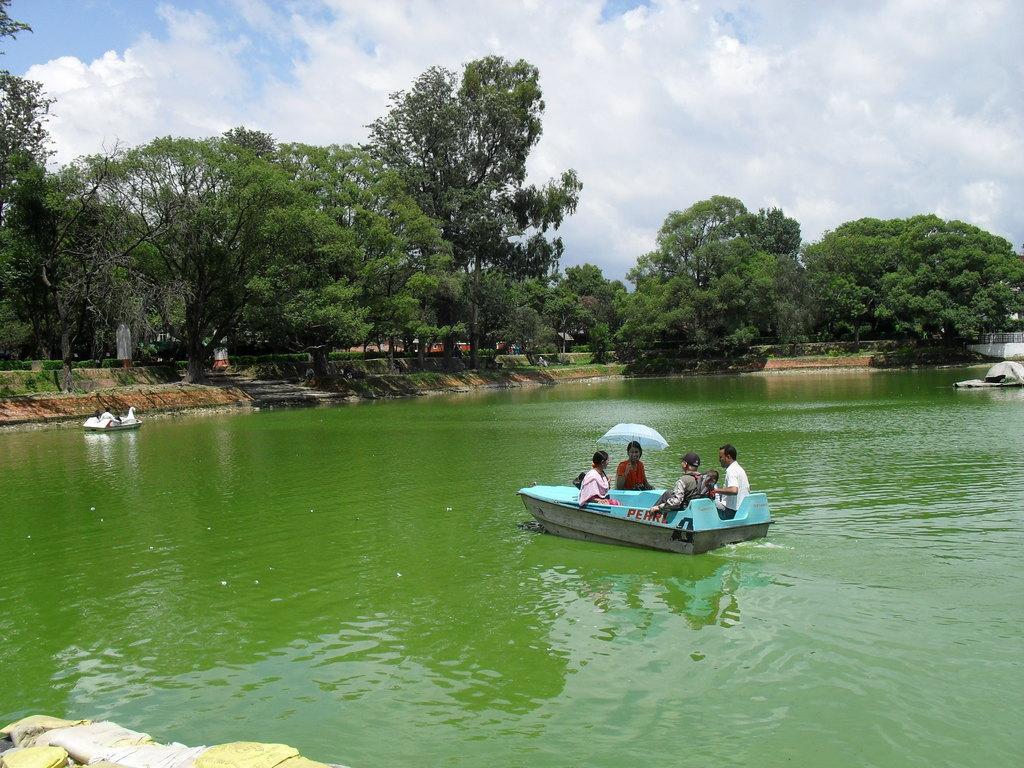In one or two sentences, can you explain what this image depicts? In this image in the center there is a boat and there are persons on the boat which is sailing on the water. In the background there are trees, there's grass on the ground and there is an object on the water which is white in colour and the sky is cloudy. 